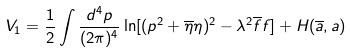<formula> <loc_0><loc_0><loc_500><loc_500>V _ { 1 } = \frac { 1 } { 2 } \int \frac { d ^ { 4 } p } { ( 2 \pi ) ^ { 4 } } \ln [ ( p ^ { 2 } + \overline { \eta } \eta ) ^ { 2 } - \lambda ^ { 2 } \overline { f } f ] + H ( \overline { a } , a )</formula> 